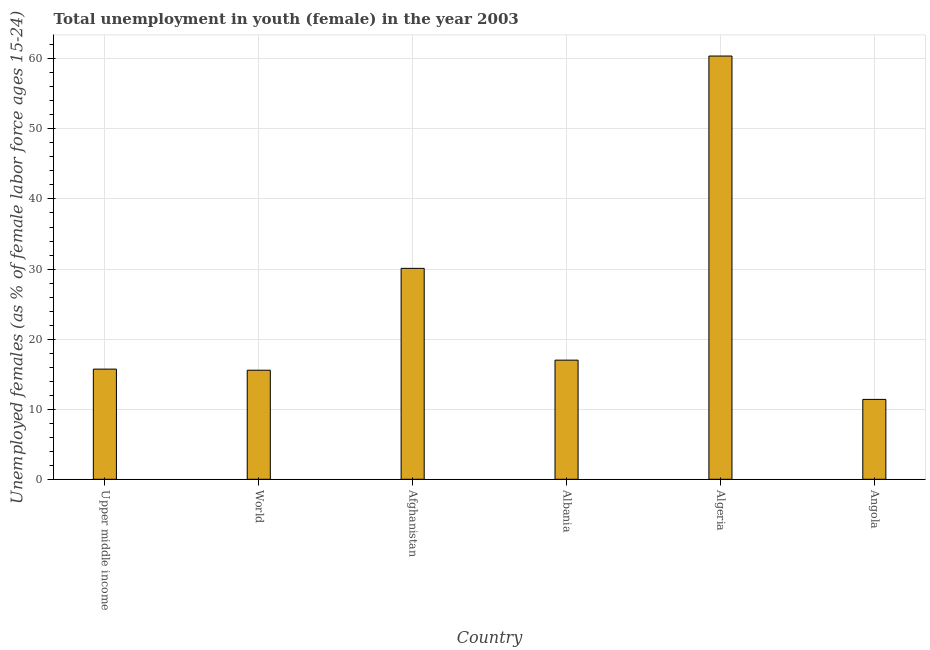What is the title of the graph?
Provide a succinct answer. Total unemployment in youth (female) in the year 2003. What is the label or title of the X-axis?
Provide a succinct answer. Country. What is the label or title of the Y-axis?
Offer a terse response. Unemployed females (as % of female labor force ages 15-24). What is the unemployed female youth population in Algeria?
Your answer should be very brief. 60.4. Across all countries, what is the maximum unemployed female youth population?
Offer a very short reply. 60.4. Across all countries, what is the minimum unemployed female youth population?
Provide a succinct answer. 11.4. In which country was the unemployed female youth population maximum?
Provide a short and direct response. Algeria. In which country was the unemployed female youth population minimum?
Your answer should be very brief. Angola. What is the sum of the unemployed female youth population?
Provide a short and direct response. 150.19. What is the difference between the unemployed female youth population in Angola and Upper middle income?
Offer a terse response. -4.32. What is the average unemployed female youth population per country?
Give a very brief answer. 25.03. What is the median unemployed female youth population?
Ensure brevity in your answer.  16.36. What is the ratio of the unemployed female youth population in Afghanistan to that in Upper middle income?
Provide a short and direct response. 1.92. What is the difference between the highest and the second highest unemployed female youth population?
Make the answer very short. 30.3. Is the sum of the unemployed female youth population in Afghanistan and Albania greater than the maximum unemployed female youth population across all countries?
Your response must be concise. No. Are the values on the major ticks of Y-axis written in scientific E-notation?
Give a very brief answer. No. What is the Unemployed females (as % of female labor force ages 15-24) in Upper middle income?
Make the answer very short. 15.72. What is the Unemployed females (as % of female labor force ages 15-24) in World?
Offer a terse response. 15.56. What is the Unemployed females (as % of female labor force ages 15-24) of Afghanistan?
Ensure brevity in your answer.  30.1. What is the Unemployed females (as % of female labor force ages 15-24) of Algeria?
Make the answer very short. 60.4. What is the Unemployed females (as % of female labor force ages 15-24) in Angola?
Make the answer very short. 11.4. What is the difference between the Unemployed females (as % of female labor force ages 15-24) in Upper middle income and World?
Provide a succinct answer. 0.16. What is the difference between the Unemployed females (as % of female labor force ages 15-24) in Upper middle income and Afghanistan?
Offer a terse response. -14.38. What is the difference between the Unemployed females (as % of female labor force ages 15-24) in Upper middle income and Albania?
Provide a succinct answer. -1.28. What is the difference between the Unemployed females (as % of female labor force ages 15-24) in Upper middle income and Algeria?
Provide a succinct answer. -44.68. What is the difference between the Unemployed females (as % of female labor force ages 15-24) in Upper middle income and Angola?
Offer a terse response. 4.32. What is the difference between the Unemployed females (as % of female labor force ages 15-24) in World and Afghanistan?
Make the answer very short. -14.54. What is the difference between the Unemployed females (as % of female labor force ages 15-24) in World and Albania?
Your answer should be compact. -1.44. What is the difference between the Unemployed females (as % of female labor force ages 15-24) in World and Algeria?
Keep it short and to the point. -44.84. What is the difference between the Unemployed females (as % of female labor force ages 15-24) in World and Angola?
Offer a very short reply. 4.16. What is the difference between the Unemployed females (as % of female labor force ages 15-24) in Afghanistan and Algeria?
Provide a succinct answer. -30.3. What is the difference between the Unemployed females (as % of female labor force ages 15-24) in Afghanistan and Angola?
Offer a terse response. 18.7. What is the difference between the Unemployed females (as % of female labor force ages 15-24) in Albania and Algeria?
Offer a terse response. -43.4. What is the difference between the Unemployed females (as % of female labor force ages 15-24) in Albania and Angola?
Ensure brevity in your answer.  5.6. What is the difference between the Unemployed females (as % of female labor force ages 15-24) in Algeria and Angola?
Your response must be concise. 49. What is the ratio of the Unemployed females (as % of female labor force ages 15-24) in Upper middle income to that in World?
Your answer should be compact. 1.01. What is the ratio of the Unemployed females (as % of female labor force ages 15-24) in Upper middle income to that in Afghanistan?
Your answer should be compact. 0.52. What is the ratio of the Unemployed females (as % of female labor force ages 15-24) in Upper middle income to that in Albania?
Offer a very short reply. 0.93. What is the ratio of the Unemployed females (as % of female labor force ages 15-24) in Upper middle income to that in Algeria?
Make the answer very short. 0.26. What is the ratio of the Unemployed females (as % of female labor force ages 15-24) in Upper middle income to that in Angola?
Your answer should be compact. 1.38. What is the ratio of the Unemployed females (as % of female labor force ages 15-24) in World to that in Afghanistan?
Your answer should be compact. 0.52. What is the ratio of the Unemployed females (as % of female labor force ages 15-24) in World to that in Albania?
Ensure brevity in your answer.  0.92. What is the ratio of the Unemployed females (as % of female labor force ages 15-24) in World to that in Algeria?
Ensure brevity in your answer.  0.26. What is the ratio of the Unemployed females (as % of female labor force ages 15-24) in World to that in Angola?
Make the answer very short. 1.36. What is the ratio of the Unemployed females (as % of female labor force ages 15-24) in Afghanistan to that in Albania?
Your answer should be very brief. 1.77. What is the ratio of the Unemployed females (as % of female labor force ages 15-24) in Afghanistan to that in Algeria?
Ensure brevity in your answer.  0.5. What is the ratio of the Unemployed females (as % of female labor force ages 15-24) in Afghanistan to that in Angola?
Ensure brevity in your answer.  2.64. What is the ratio of the Unemployed females (as % of female labor force ages 15-24) in Albania to that in Algeria?
Provide a succinct answer. 0.28. What is the ratio of the Unemployed females (as % of female labor force ages 15-24) in Albania to that in Angola?
Provide a succinct answer. 1.49. What is the ratio of the Unemployed females (as % of female labor force ages 15-24) in Algeria to that in Angola?
Your answer should be very brief. 5.3. 